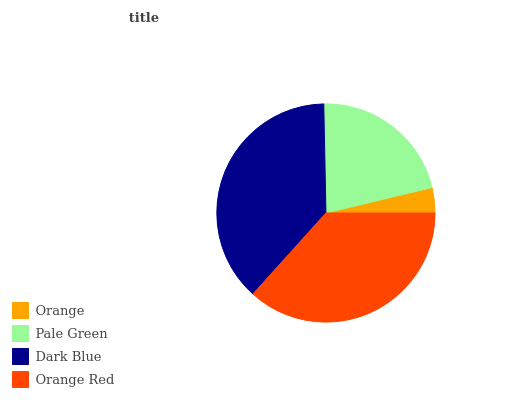Is Orange the minimum?
Answer yes or no. Yes. Is Dark Blue the maximum?
Answer yes or no. Yes. Is Pale Green the minimum?
Answer yes or no. No. Is Pale Green the maximum?
Answer yes or no. No. Is Pale Green greater than Orange?
Answer yes or no. Yes. Is Orange less than Pale Green?
Answer yes or no. Yes. Is Orange greater than Pale Green?
Answer yes or no. No. Is Pale Green less than Orange?
Answer yes or no. No. Is Orange Red the high median?
Answer yes or no. Yes. Is Pale Green the low median?
Answer yes or no. Yes. Is Orange the high median?
Answer yes or no. No. Is Dark Blue the low median?
Answer yes or no. No. 